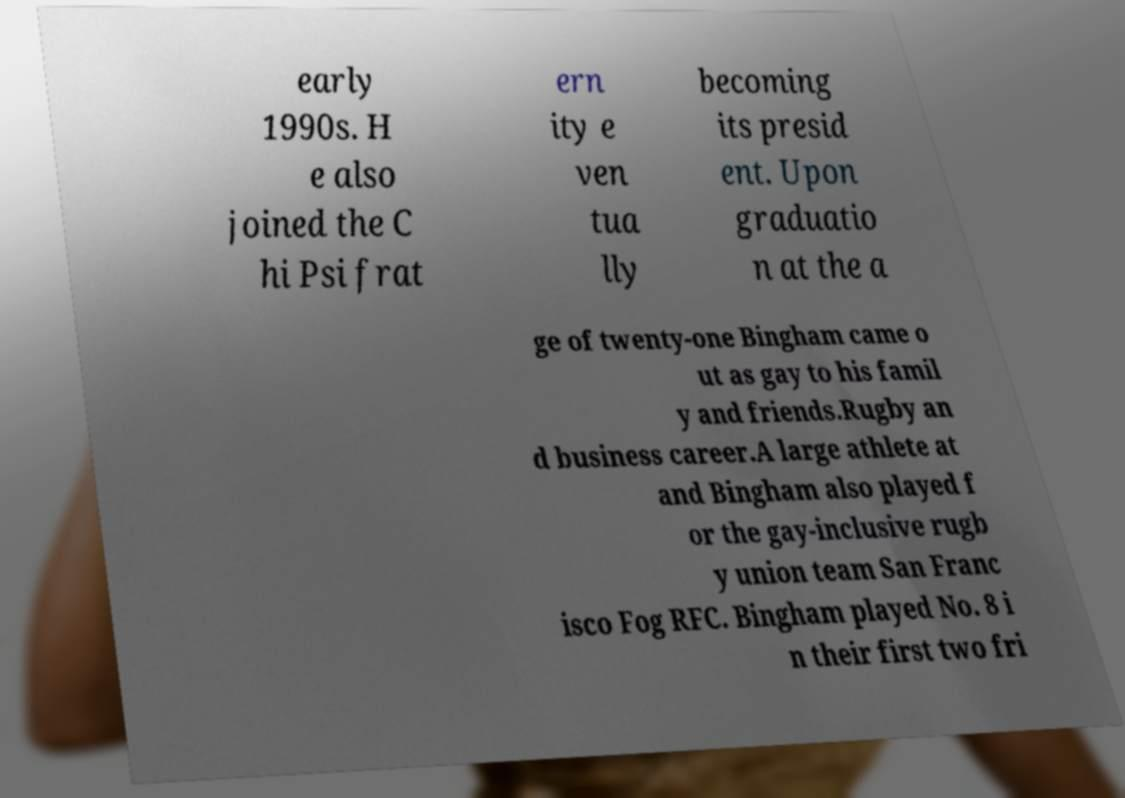Please identify and transcribe the text found in this image. early 1990s. H e also joined the C hi Psi frat ern ity e ven tua lly becoming its presid ent. Upon graduatio n at the a ge of twenty-one Bingham came o ut as gay to his famil y and friends.Rugby an d business career.A large athlete at and Bingham also played f or the gay-inclusive rugb y union team San Franc isco Fog RFC. Bingham played No. 8 i n their first two fri 